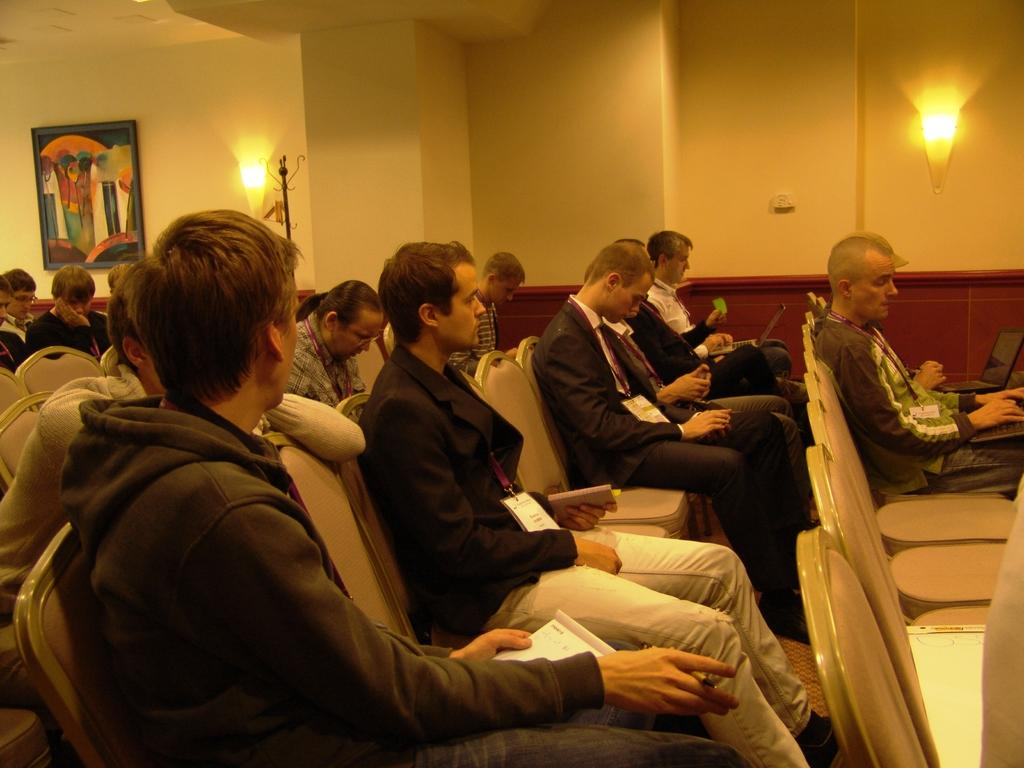What is happening with the group of people in the image? The people in the image are holding ID cards and sitting on chairs. What objects can be seen in the image that are related to technology? There are laptops in the image. What items can be seen in the image that are related to learning or studying? There are books in the image. What type of lighting is present in the image? There are lights in the image. What structure is present in the image that might be used for support or display? There is a stand in the image. What can be seen on the wall in the background of the image? There is a frame on the wall in the background of the image. How does the group of people measure their attention span in the image? There is no indication in the image that the group of people is measuring their attention span. 